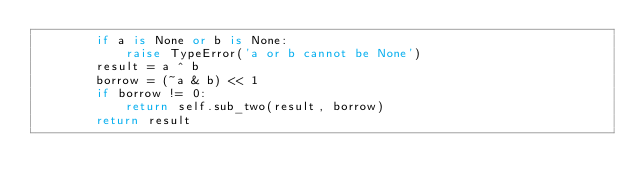Convert code to text. <code><loc_0><loc_0><loc_500><loc_500><_Python_>        if a is None or b is None:
            raise TypeError('a or b cannot be None')
        result = a ^ b
        borrow = (~a & b) << 1
        if borrow != 0:
            return self.sub_two(result, borrow)
        return result</code> 